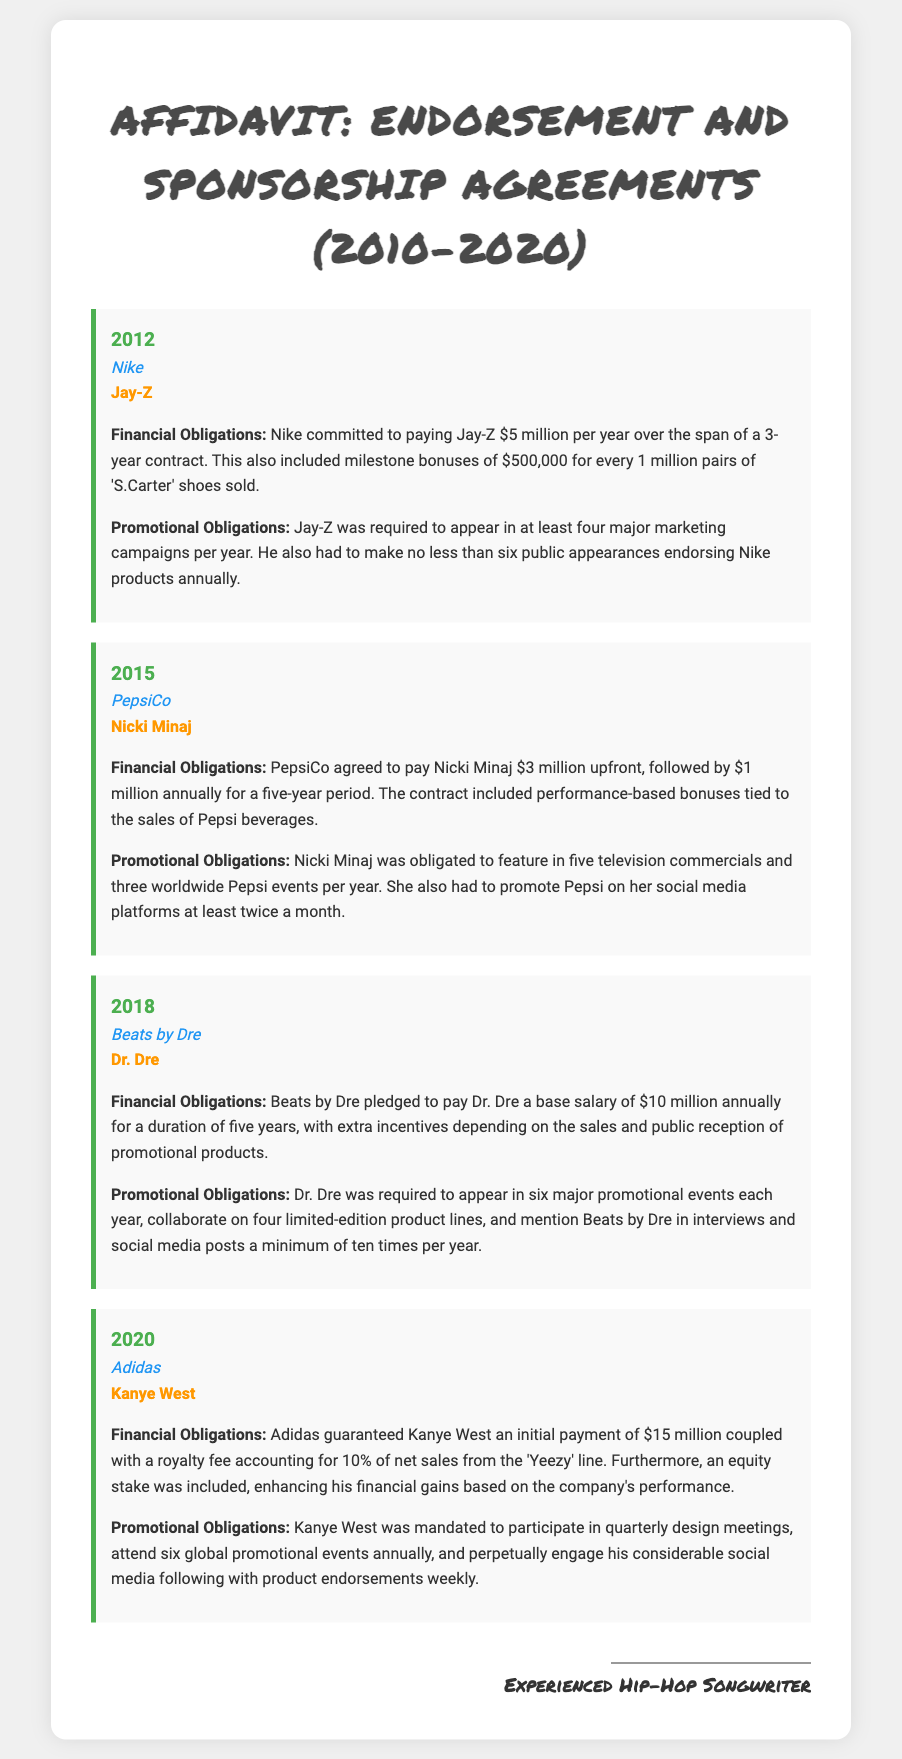What year did Jay-Z sign the agreement with Nike? The document states that Jay-Z signed the agreement with Nike in 2012.
Answer: 2012 How much was Nicki Minaj paid upfront by PepsiCo? According to the document, Nicki Minaj was paid $3 million upfront by PepsiCo.
Answer: $3 million What was the annual payment to Dr. Dre from Beats by Dre? The document indicates that Dr. Dre received a base salary of $10 million annually from Beats by Dre.
Answer: $10 million How many global promotional events was Kanye West required to attend annually? The document outlines that Kanye West was mandated to attend six global promotional events each year.
Answer: Six What bonus did Nike provide Jay-Z for every million pairs of shoes sold? The document specifies that Nike provided Jay-Z with a milestone bonus of $500,000 for every 1 million pairs of 'S.Carter' shoes sold.
Answer: $500,000 What was the duration of Nicki Minaj's contract with PepsiCo? The document indicates that Nicki Minaj's contract with PepsiCo lasted five years.
Answer: Five years What percentage of net sales from the 'Yeezy' line is Kanye West's royalty fee? According to the document, Kanye West's royalty fee from the 'Yeezy' line is 10% of net sales.
Answer: 10% How many major marketing campaigns was Jay-Z required to appear in each year? The document states that Jay-Z was required to appear in at least four major marketing campaigns per year.
Answer: Four What entity was involved in an agreement with Dr. Dre in 2018? The document mentions that Dr. Dre had an agreement with Beats by Dre in 2018.
Answer: Beats by Dre 